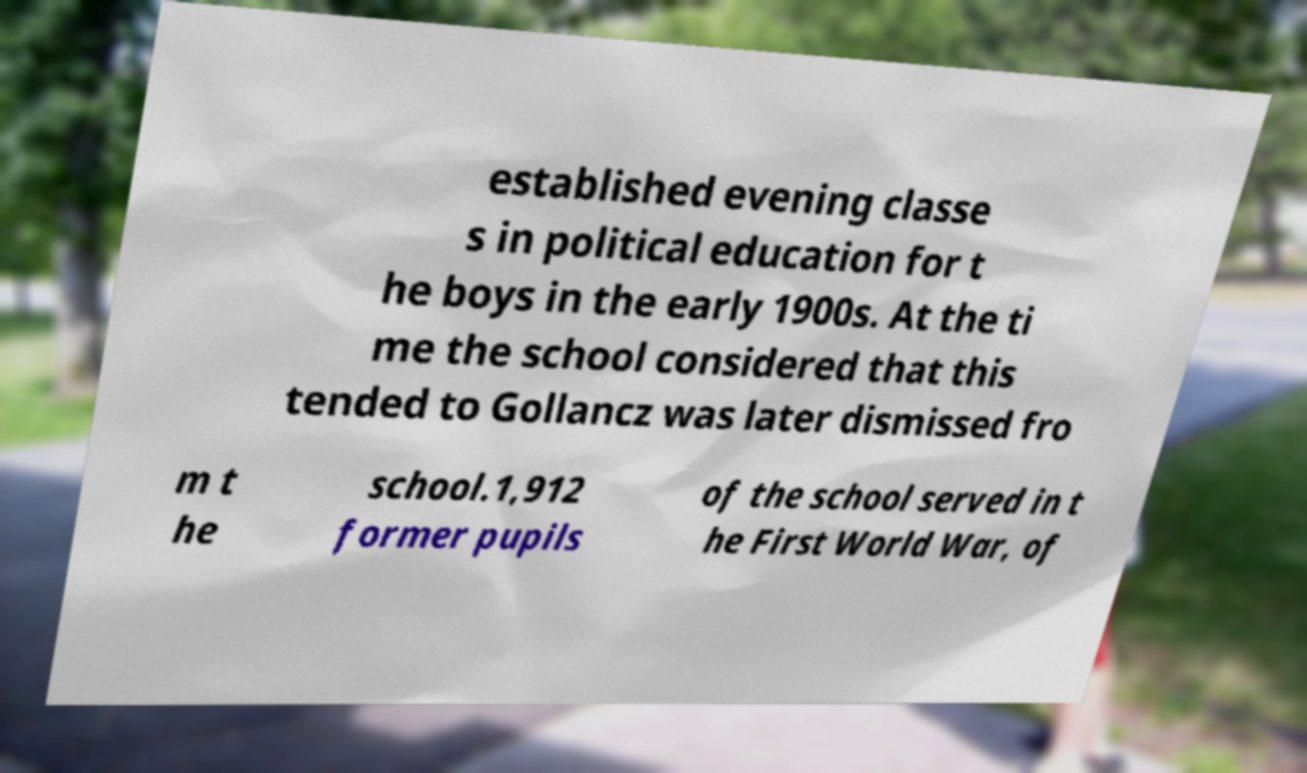Could you extract and type out the text from this image? established evening classe s in political education for t he boys in the early 1900s. At the ti me the school considered that this tended to Gollancz was later dismissed fro m t he school.1,912 former pupils of the school served in t he First World War, of 